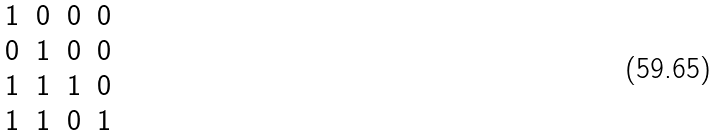Convert formula to latex. <formula><loc_0><loc_0><loc_500><loc_500>\begin{matrix} 1 & 0 & 0 & 0 \\ 0 & 1 & 0 & 0 \\ 1 & 1 & 1 & 0 \\ 1 & 1 & 0 & 1 \\ \end{matrix}</formula> 